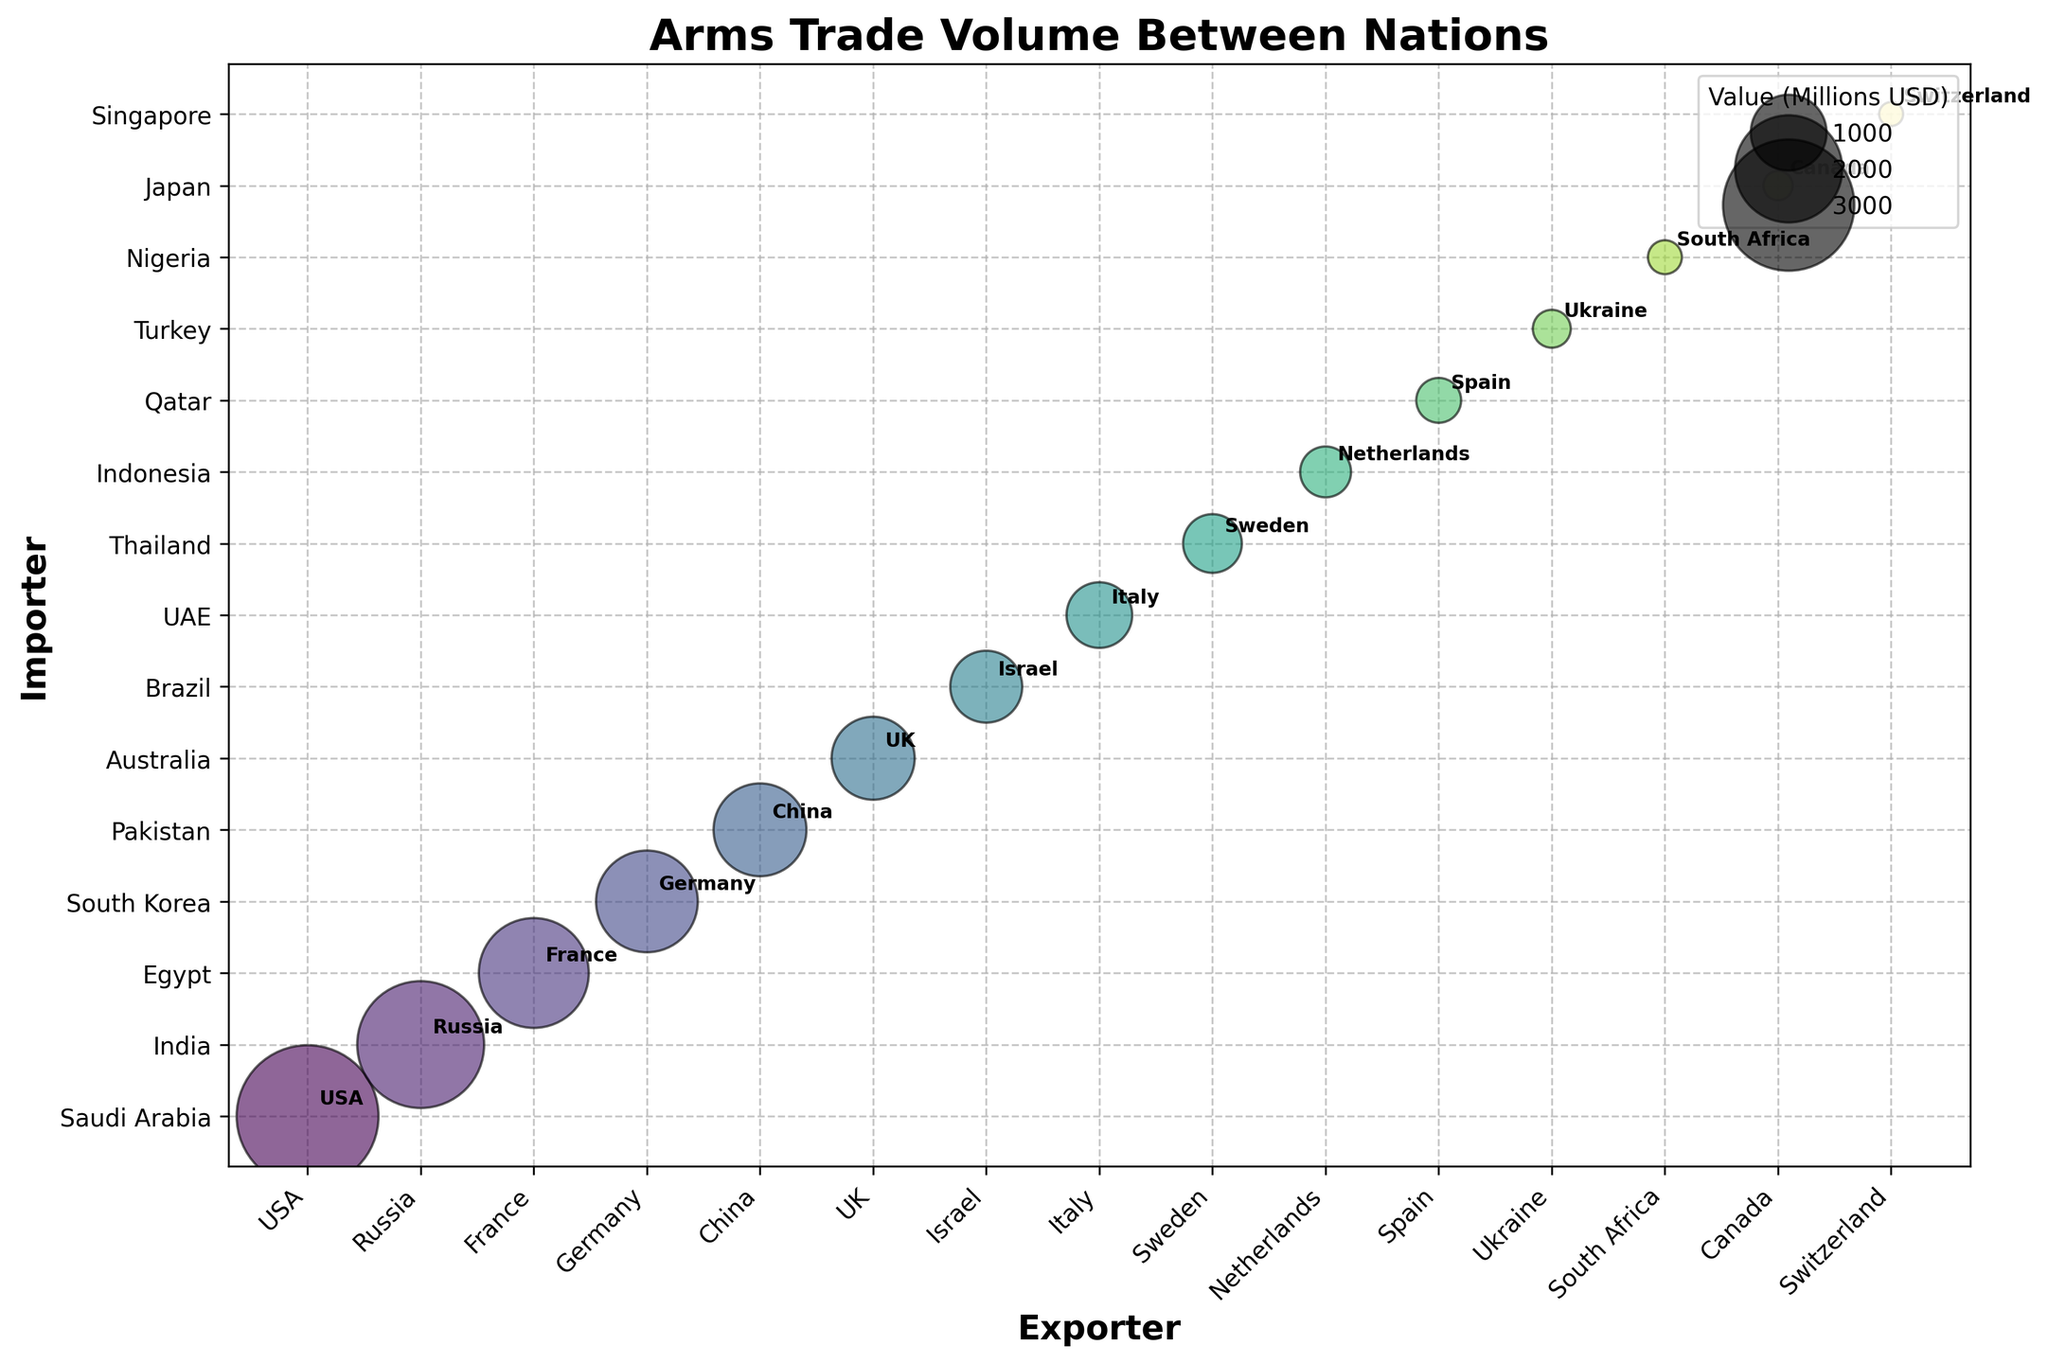Which country has the highest arms trade value as an exporter? The largest bubble corresponds to the USA exporting to Saudi Arabia, which is the highest value at 3500 million USD.
Answer: USA How many exporters are shown in the bubble chart? The x-axis labels represent the exporters, and there are 15 different exporters shown.
Answer: 15 Which importer has the smallest arms trade value, and what is the value? Finding the smallest bubble, it corresponds to Singapore importing from Switzerland with a value of 100 million USD.
Answer: Singapore, 100 What is the total trade value for all the countries listed? Summing up all the given values: 3500 + 2800 + 2100 + 1800 + 1500 + 1200 + 900 + 750 + 600 + 450 + 350 + 250 + 200 + 150 + 100 equals 17650 million USD.
Answer: 17650 Which exporter trades with the highest number of different importers according to the chart? By counting the number of unique importers for each exporter, it seems every exporter trades with one different importer, so each has the same number.
Answer: All exporters have 1 importer Compare the arms trade volumes of Russia and China. Which is greater and by how much? Russia trades 2800 million USD to India and China trades 1500 million USD to Pakistan. The difference is 2800 - 1500 = 1300 million USD.
Answer: Russia, 1300 Which pair of nations has the smallest trade value, and how many times larger is the highest value compared to it? The pair with the smallest trade value is Switzerland-Singapore at 100 million USD, and the highest is USA-Saudi Arabia at 3500 million USD. 3500 / 100 = 35 times larger.
Answer: Switzerland-Singapore, 35 times What is the total trade value for nations importing arms from European countries (France, Germany, UK, Italy, Sweden, Netherlands, Spain, Switzerland)? Summing the values for importers of European exports: 2100 (France) + 1800 (Germany) + 1200 (UK) + 750 (Italy) + 600 (Sweden) + 450 (Netherlands) + 350 (Spain) + 100 (Switzerland) = 7350 million USD.
Answer: 7350 What percentage of the total trade value is represented by the USA's exports to Saudi Arabia? The total trade value is 17650 million USD. The USA's exports to Saudi Arabia are 3500 million USD. The percentage is (3500 / 17650) * 100 = 19.82%.
Answer: 19.82% Identify which countries export arms to nations outside their own continent and provide an example. By analyzing the exporters and importers, examples include the USA exporting to Saudi Arabia (North America to Asia) and France exporting to Egypt (Europe to Africa).
Answer: USA and France 